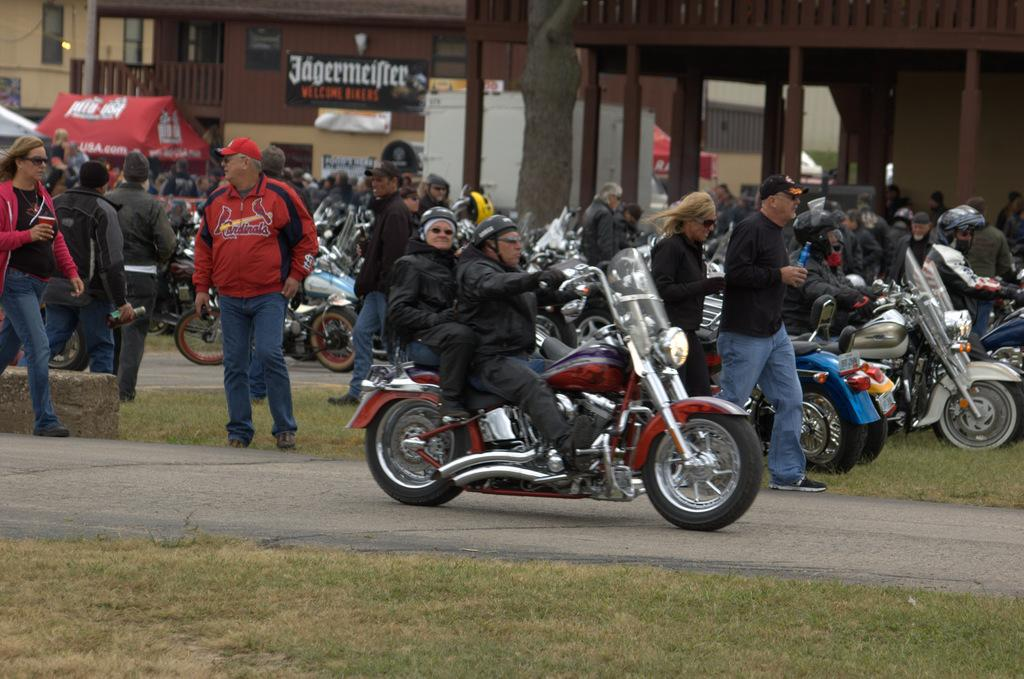What are the two persons doing in the middle of the image? There are two persons sitting on a bike in the middle of the image. What are the people on the left side of the image doing? A woman and a man are walking on the left side of the image. What type of vegetation is visible in the image? There is grass visible in the image. What structures can be seen in the middle of the image? There are buildings in the middle of the image. What type of dress is the bike wearing in the image? The bike is not wearing a dress; it is an inanimate object and does not have the ability to wear clothing. Can you hear the bells ringing in the image? There are no bells present in the image, so it is not possible to hear them ringing. 